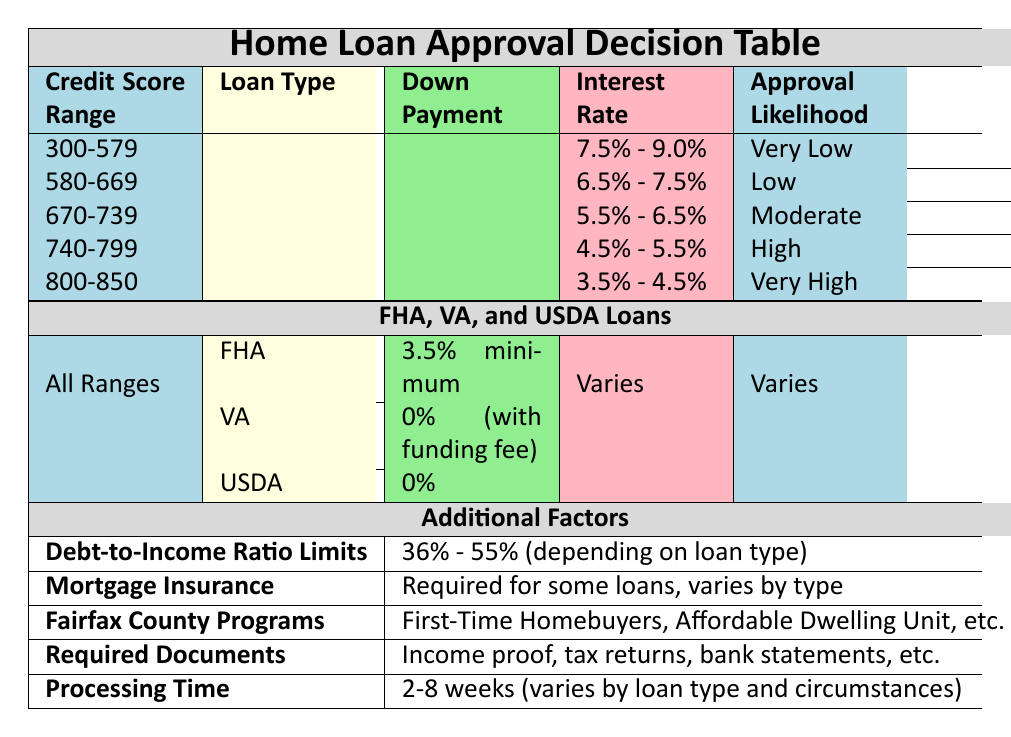What is the down payment requirement for a VA loan? According to the table, the down payment requirement for a VA loan is 0% (with funding fee).
Answer: 0% (with funding fee) What is the approval likelihood for a credit score in the range of 670-739? From the table, the approval likelihood for a credit score of 670-739 is Moderate.
Answer: Moderate True or False: A credit score of 800-850 has the lowest interest rate range listed in the table. The interest rate range for a credit score of 800-850 is 3.5% - 4.5%, which is indeed the lowest range compared to other credit score ranges, confirming the statement is true.
Answer: True What is the average down payment requirement for Conventional and FHA loans? The down payment requirement for Conventional loans is 3% minimum and for FHA is 3.5% minimum. To find the average: (3% + 3.5%) / 2 = 3.25%.
Answer: 3.25% How many weeks does the approval process take for FHA loans? The table indicates that the processing time for FHA loans is 3-4 weeks.
Answer: 3-4 weeks What is the debt-to-income ratio limit for someone applying for a USDA loan? The table states the debt-to-income ratio limits can range from 36% to 55% depending on the loan type. Since USDA generally offers more flexibility, the limit can be as high as 55%.
Answer: 55% How does the approval likelihood change from a credit score of 580-669 to a score of 740-799? The approval likelihood for a score of 580-669 is Low, while for 740-799, it is High. So, it changes from Low to High, which is a positive shift in the likelihood.
Answer: Changes from Low to High Is mortgage insurance required for a conventional loan with a down payment of 20% or more? The table specifies that mortgage insurance is only required if the down payment is less than 20%, so if the down payment is 20% or more, it is not required. Therefore, the answer is No.
Answer: No What is the interest rate range for a credit score of 740-799? The table shows that the interest rate range for a credit score of 740-799 is 4.5% - 5.5%.
Answer: 4.5% - 5.5% What are the required documents for loan approval? The table lists the required documents as proof of income, tax returns for the last 2 years, bank statements for the last 2-3 months, employment verification, proof of assets, and a photo ID.
Answer: Proof of income, tax returns, bank statements, employment verification, proof of assets, photo ID 